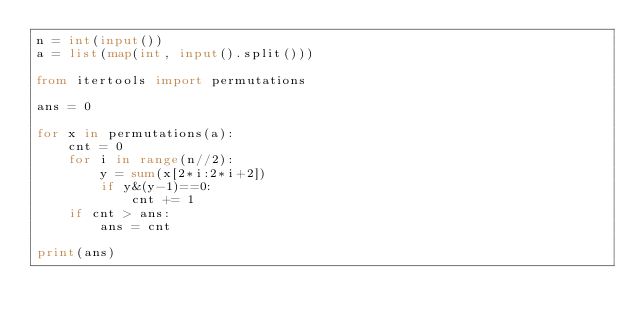Convert code to text. <code><loc_0><loc_0><loc_500><loc_500><_Python_>n = int(input())
a = list(map(int, input().split()))

from itertools import permutations

ans = 0

for x in permutations(a):
    cnt = 0
    for i in range(n//2):
        y = sum(x[2*i:2*i+2])
        if y&(y-1)==0:
            cnt += 1
    if cnt > ans:
        ans = cnt

print(ans)
</code> 